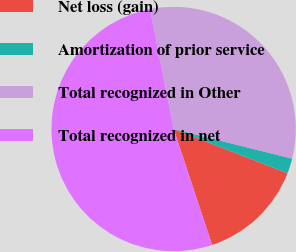<chart> <loc_0><loc_0><loc_500><loc_500><pie_chart><fcel>Net loss (gain)<fcel>Amortization of prior service<fcel>Total recognized in Other<fcel>Total recognized in net<nl><fcel>14.0%<fcel>2.0%<fcel>32.0%<fcel>52.0%<nl></chart> 